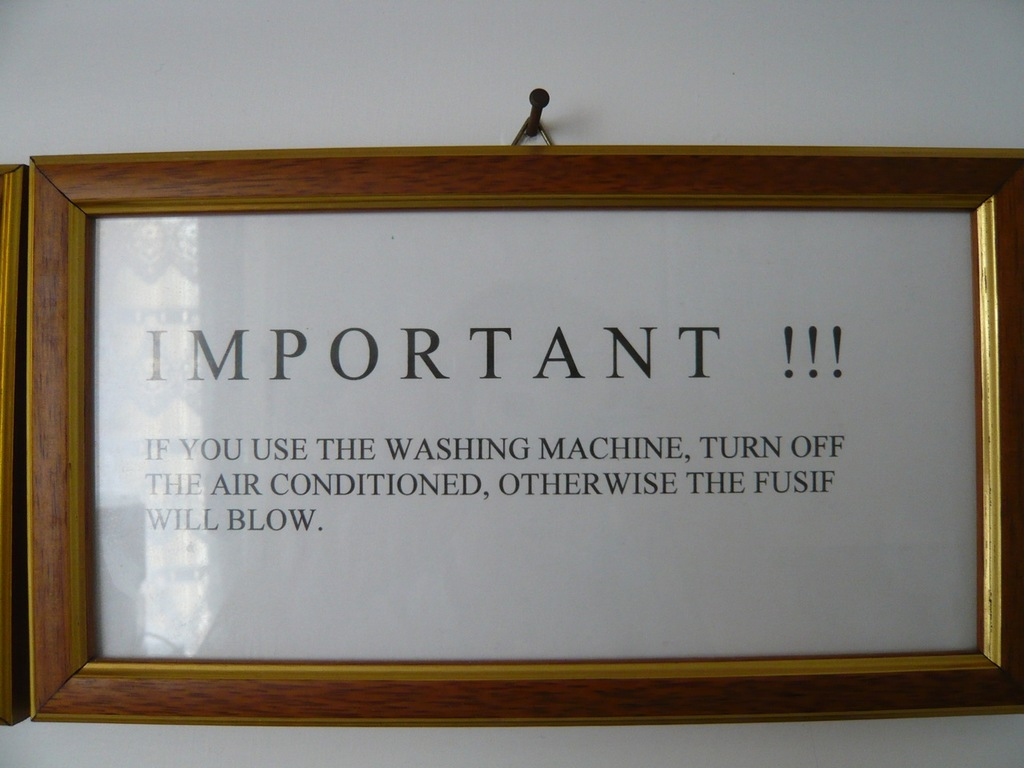Why would using both the washing machine and the air conditioner at the same time cause the fuse to blow? Using both appliances simultaneously can cause the fuse to blow because each unit likely consumes a significant amount of electrical power. Many residential and older buildings have electrical systems that can't cope with high power demands from multiple major appliances running at the same time. This overloads the circuit, exceeding the safe carrying capacity of the wires and the fuse, leading to the fuse 'blowing' to prevent overheating and fire risks. 